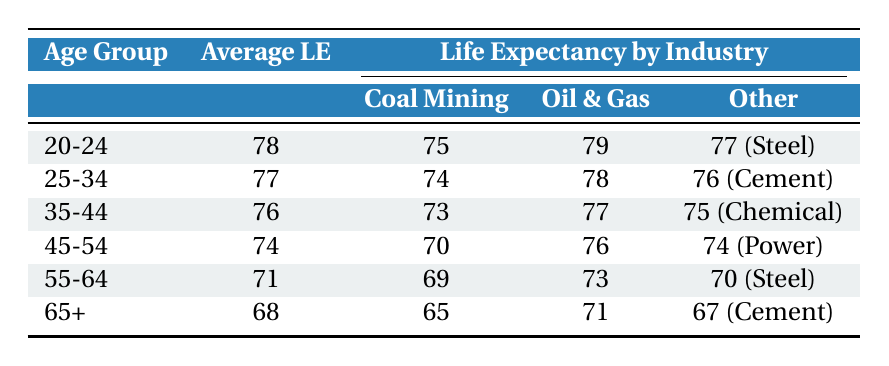What is the average life expectancy of workers aged 20-24 in high-emission industries? The average life expectancy for the age group 20-24 is stated directly in the table as 78 years.
Answer: 78 Which industry has the lowest life expectancy for workers aged 45-54? In the age group 45-54, the life expectancy for Coal Mining is 70 years, which is lower than the others (76 for Oil & Gas and 74 for Power Generation).
Answer: Coal Mining What is the difference in life expectancy between Oil & Gas Extraction workers aged 35-44 and those aged 25-34? For Oil & Gas Extraction, the life expectancy for 35-44 is 77 years and for 25-34 it is 78 years. The difference is 78 - 77 = 1 year.
Answer: 1 Are workers in the Cement Production industry expected to live longer than those in the Coal Mining industry across all age groups? In the age group 25-34, Cement Production has a life expectancy of 76 years while Coal Mining has 74 years; however, in the age group 65+, Cement Production has 67 years compared to Coal Mining's 65 years. But in the age groups 20-24, 35-44, and 55-64, Coal Mining has a higher expectancy. Thus, Cement Production does not have a longer expectancy in every age group.
Answer: No What is the total life expectancy for all industries combined for workers aged 55-64? For the age group 55-64, life expectancy for each industry is Coal Mining 69, Oil & Gas 73, and Steel Manufacturing 70. The total is 69 + 73 + 70 = 212.
Answer: 212 Which age group has the highest average life expectancy and what is that expectancy? The age group with the highest average life expectancy is 20-24 with an average of 78 years.
Answer: 20-24, 78 How much lower is the average life expectancy for workers aged 65+ compared to those aged 25-34? The average for 65+ is 68 years and for 25-34, it is 77 years. The difference is 77 - 68 = 9 years.
Answer: 9 Is the life expectancy for workers in the Oil & Gas Extraction industry in the 55-64 age group higher than their counterparts in the Chemical Manufacturing industry in the same group? The life expectancy for Oil & Gas Extraction workers aged 55-64 is 73 years, whereas for Chemical Manufacturing, it is 75 years. Therefore, Oil & Gas has a lower life expectancy than Chemical Manufacturing.
Answer: No What is the average life expectancy for workers in the Coal Mining industry across all age groups presented? The life expectancies for Coal Mining are 75 (20-24), 74 (25-34), 73 (35-44), 70 (45-54), 69 (55-64), and 65 (65+). The average is (75 + 74 + 73 + 70 + 69 + 65)/6 = 71
Answer: 71 